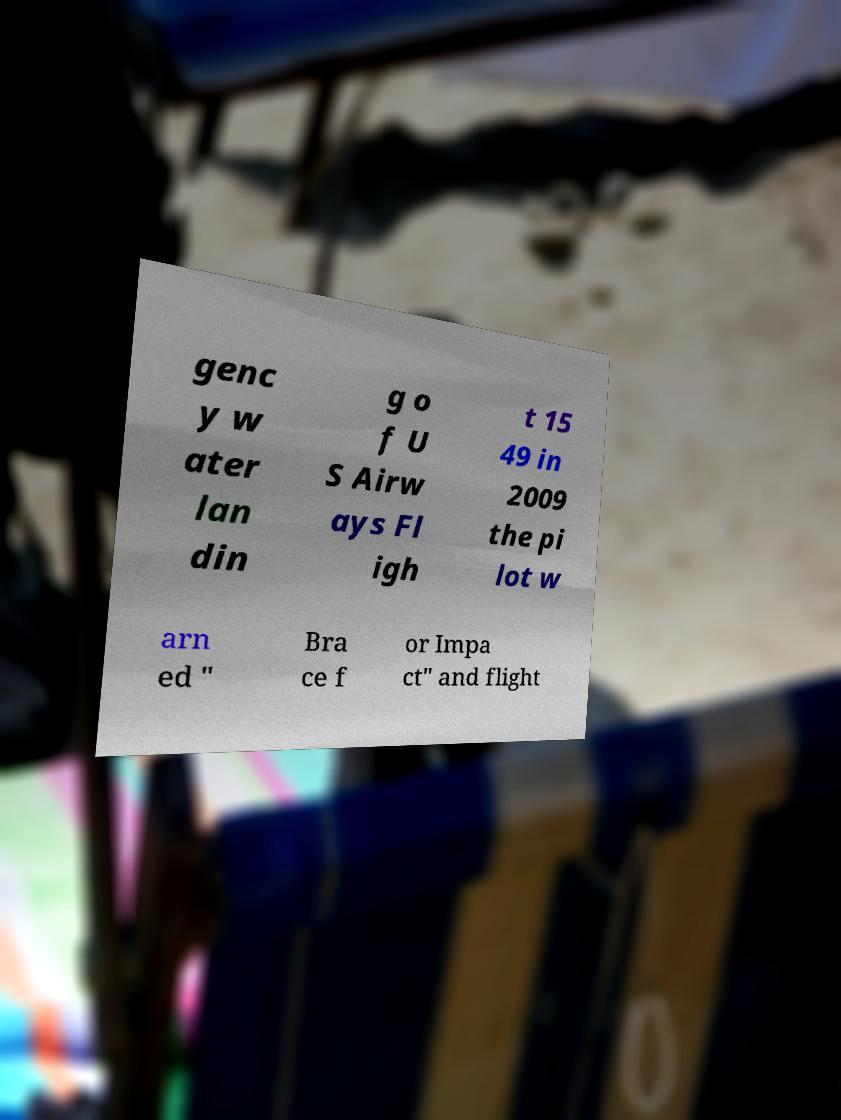Please read and relay the text visible in this image. What does it say? genc y w ater lan din g o f U S Airw ays Fl igh t 15 49 in 2009 the pi lot w arn ed " Bra ce f or Impa ct" and flight 